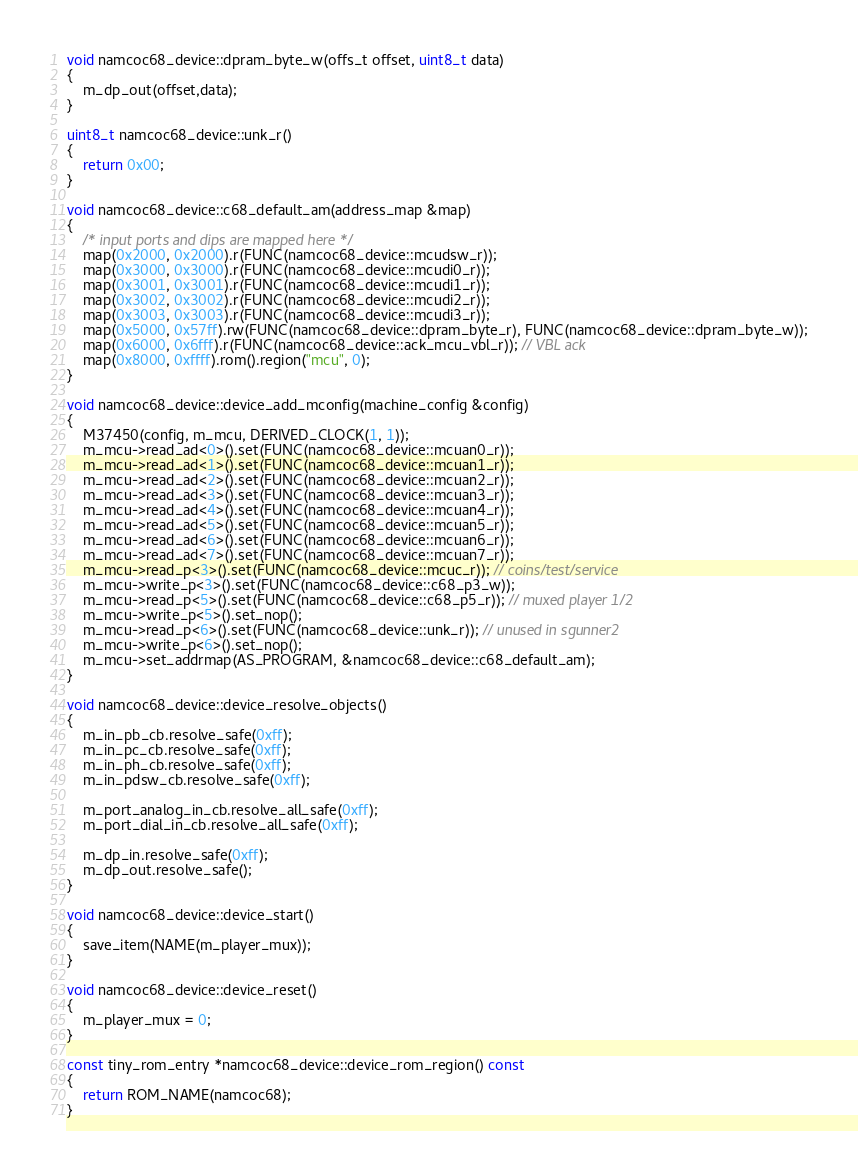<code> <loc_0><loc_0><loc_500><loc_500><_C++_>void namcoc68_device::dpram_byte_w(offs_t offset, uint8_t data)
{
	m_dp_out(offset,data);
}

uint8_t namcoc68_device::unk_r()
{
	return 0x00;
}

void namcoc68_device::c68_default_am(address_map &map)
{
	/* input ports and dips are mapped here */
	map(0x2000, 0x2000).r(FUNC(namcoc68_device::mcudsw_r));
	map(0x3000, 0x3000).r(FUNC(namcoc68_device::mcudi0_r));
	map(0x3001, 0x3001).r(FUNC(namcoc68_device::mcudi1_r));
	map(0x3002, 0x3002).r(FUNC(namcoc68_device::mcudi2_r));
	map(0x3003, 0x3003).r(FUNC(namcoc68_device::mcudi3_r));
	map(0x5000, 0x57ff).rw(FUNC(namcoc68_device::dpram_byte_r), FUNC(namcoc68_device::dpram_byte_w));
	map(0x6000, 0x6fff).r(FUNC(namcoc68_device::ack_mcu_vbl_r)); // VBL ack
	map(0x8000, 0xffff).rom().region("mcu", 0);
}

void namcoc68_device::device_add_mconfig(machine_config &config)
{
	M37450(config, m_mcu, DERIVED_CLOCK(1, 1));
	m_mcu->read_ad<0>().set(FUNC(namcoc68_device::mcuan0_r));
	m_mcu->read_ad<1>().set(FUNC(namcoc68_device::mcuan1_r));
	m_mcu->read_ad<2>().set(FUNC(namcoc68_device::mcuan2_r));
	m_mcu->read_ad<3>().set(FUNC(namcoc68_device::mcuan3_r));
	m_mcu->read_ad<4>().set(FUNC(namcoc68_device::mcuan4_r));
	m_mcu->read_ad<5>().set(FUNC(namcoc68_device::mcuan5_r));
	m_mcu->read_ad<6>().set(FUNC(namcoc68_device::mcuan6_r));
	m_mcu->read_ad<7>().set(FUNC(namcoc68_device::mcuan7_r));
	m_mcu->read_p<3>().set(FUNC(namcoc68_device::mcuc_r)); // coins/test/service
	m_mcu->write_p<3>().set(FUNC(namcoc68_device::c68_p3_w));
	m_mcu->read_p<5>().set(FUNC(namcoc68_device::c68_p5_r)); // muxed player 1/2
	m_mcu->write_p<5>().set_nop();
	m_mcu->read_p<6>().set(FUNC(namcoc68_device::unk_r)); // unused in sgunner2
	m_mcu->write_p<6>().set_nop();
	m_mcu->set_addrmap(AS_PROGRAM, &namcoc68_device::c68_default_am);
}

void namcoc68_device::device_resolve_objects()
{
	m_in_pb_cb.resolve_safe(0xff);
	m_in_pc_cb.resolve_safe(0xff);
	m_in_ph_cb.resolve_safe(0xff);
	m_in_pdsw_cb.resolve_safe(0xff);

	m_port_analog_in_cb.resolve_all_safe(0xff);
	m_port_dial_in_cb.resolve_all_safe(0xff);

	m_dp_in.resolve_safe(0xff);
	m_dp_out.resolve_safe();
}

void namcoc68_device::device_start()
{
	save_item(NAME(m_player_mux));
}

void namcoc68_device::device_reset()
{
	m_player_mux = 0;
}

const tiny_rom_entry *namcoc68_device::device_rom_region() const
{
	return ROM_NAME(namcoc68);
}
</code> 